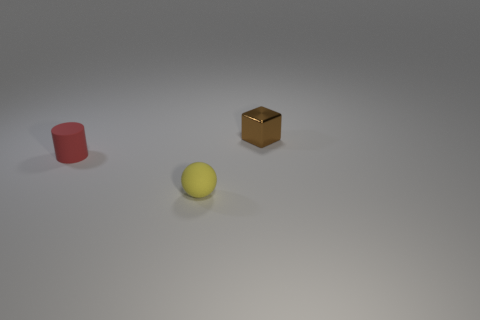There is a small rubber object that is behind the object in front of the red matte cylinder; how many brown cubes are in front of it?
Offer a terse response. 0. Does the object that is on the left side of the small matte ball have the same material as the tiny object that is right of the small sphere?
Your answer should be very brief. No. What number of tiny red matte things have the same shape as the tiny brown metal thing?
Offer a terse response. 0. Are there more spheres in front of the small red thing than things?
Your answer should be compact. No. What is the shape of the object that is in front of the small rubber thing behind the matte thing on the right side of the red cylinder?
Your answer should be compact. Sphere. Is the shape of the tiny object that is right of the yellow matte object the same as the tiny matte thing to the right of the red cylinder?
Offer a terse response. No. Is there anything else that has the same size as the shiny block?
Provide a succinct answer. Yes. How many cylinders are tiny shiny objects or small yellow objects?
Offer a very short reply. 0. Are the small cube and the cylinder made of the same material?
Your response must be concise. No. What number of other things are there of the same color as the shiny block?
Your response must be concise. 0. 